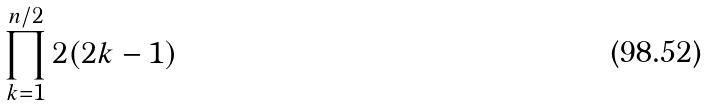Convert formula to latex. <formula><loc_0><loc_0><loc_500><loc_500>\prod _ { k = 1 } ^ { n / 2 } 2 ( 2 k - 1 )</formula> 